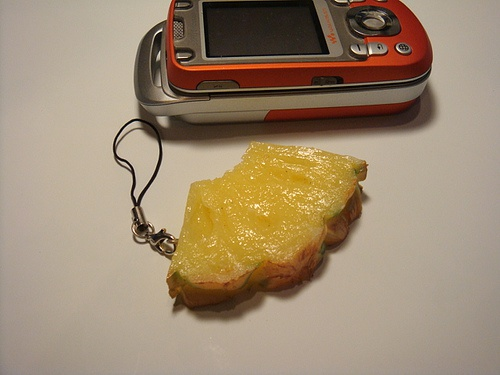Describe the objects in this image and their specific colors. I can see a cell phone in darkgray, black, maroon, and gray tones in this image. 